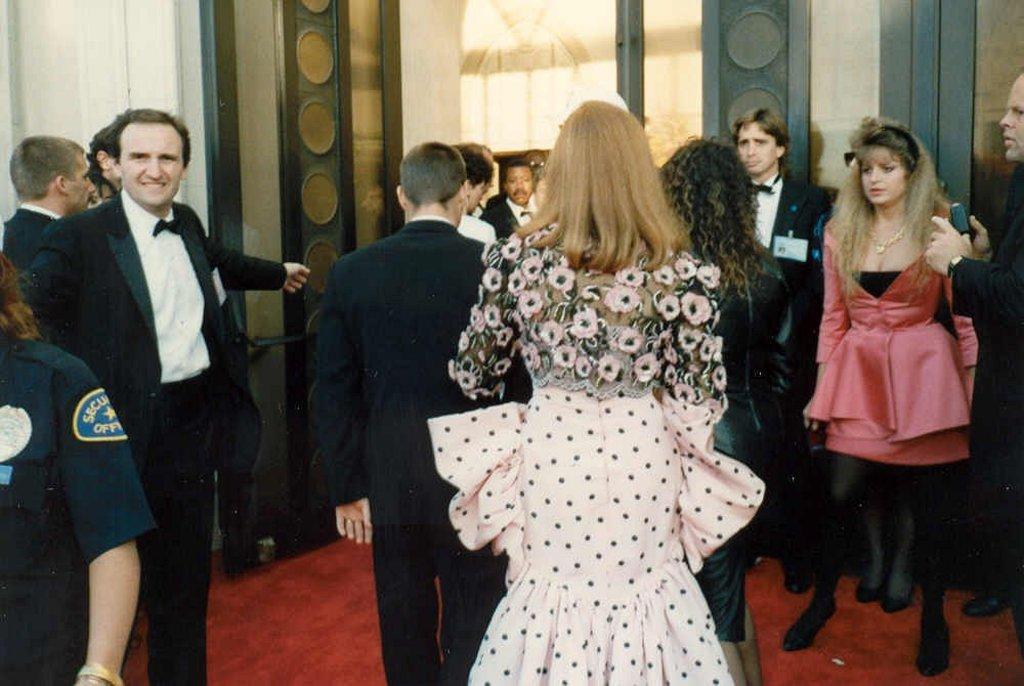In one or two sentences, can you explain what this image depicts? In the picture we can see some men are standing outside the door and welcoming some people and they are in black color blazers and to the path we can see a red color carpet and we can see a door. 